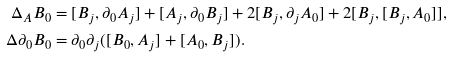<formula> <loc_0><loc_0><loc_500><loc_500>\Delta _ { A } B _ { 0 } = & \ [ B _ { j } , \partial _ { 0 } A _ { j } ] + [ A _ { j } , \partial _ { 0 } B _ { j } ] + 2 [ B _ { j } , \partial _ { j } A _ { 0 } ] + 2 [ B _ { j } , [ B _ { j } , A _ { 0 } ] ] , \\ \Delta \partial _ { 0 } B _ { 0 } = & \ \partial _ { 0 } \partial _ { j } ( [ B _ { 0 } , A _ { j } ] + [ A _ { 0 } , B _ { j } ] ) .</formula> 